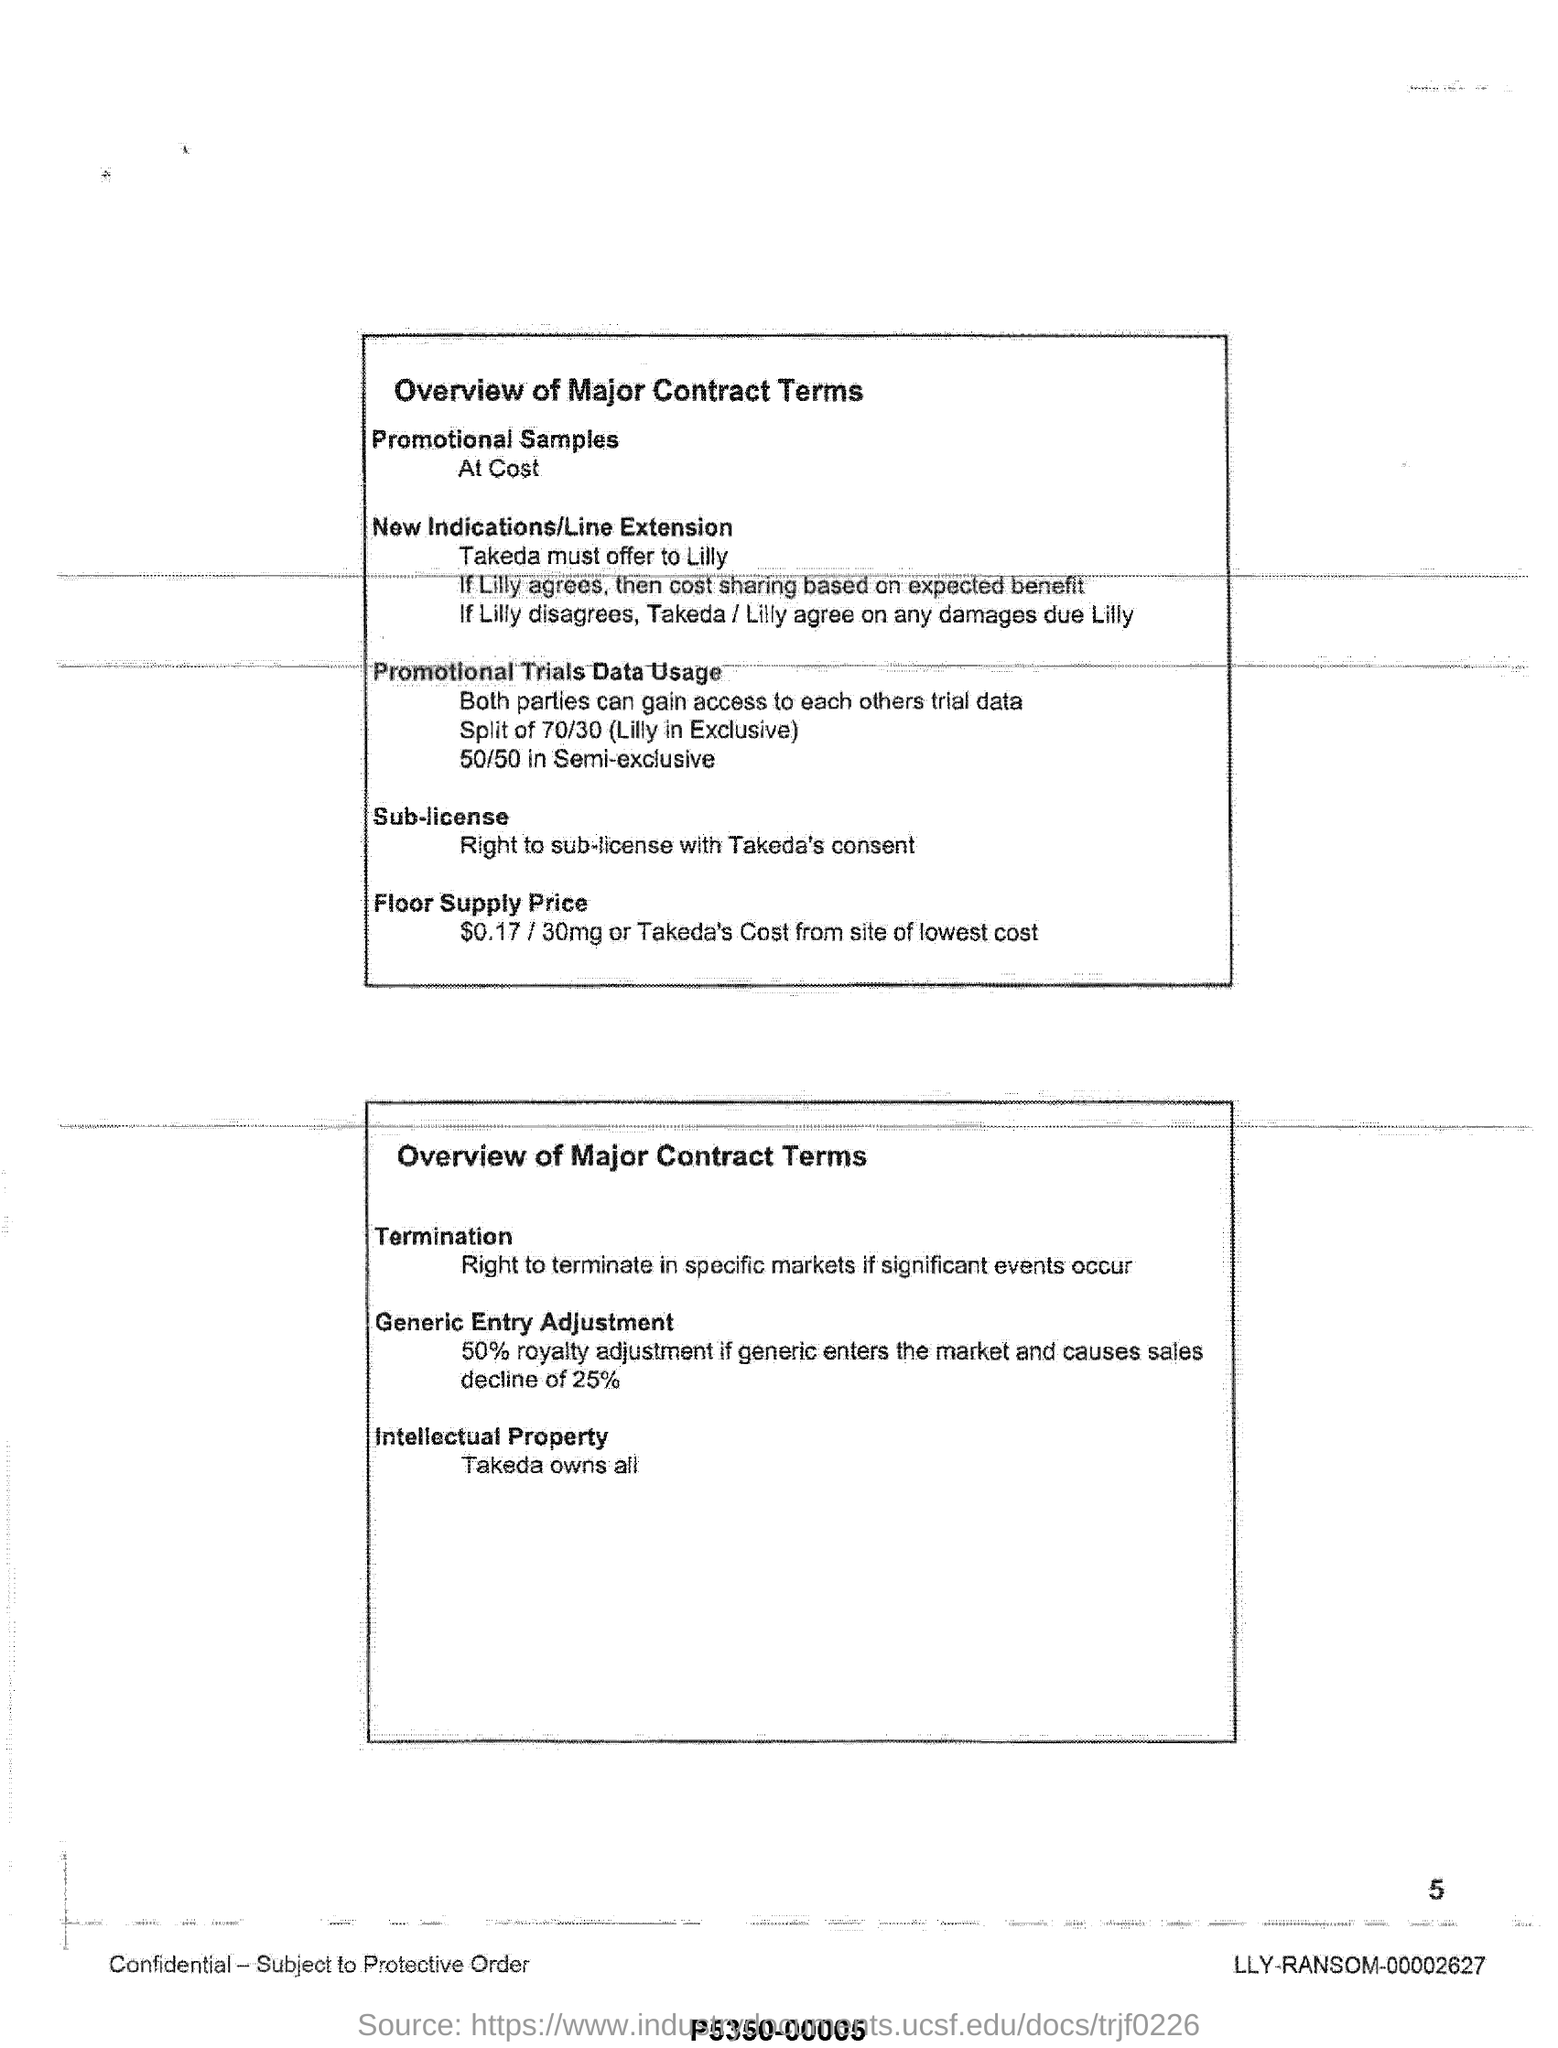What is the floor supply price?
Your answer should be compact. $0.17 / 30 mg or Takeda's cost from site of lowest cost. What is the royalty adjustment if generic enters the market ?
Provide a succinct answer. 50%. What is the promotional trails data usage  for( lilly in exclusive) ?
Offer a terse response. Split of 70/30 (lilly in exclusive). What is the promotional trials data usage for (semi exclusive)?
Ensure brevity in your answer.  50/50 in Semi-exclusive. 